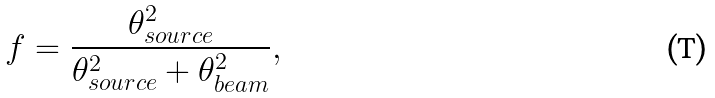Convert formula to latex. <formula><loc_0><loc_0><loc_500><loc_500>f = \frac { \theta _ { s o u r c e } ^ { 2 } } { \theta _ { s o u r c e } ^ { 2 } + \theta _ { b e a m } ^ { 2 } } ,</formula> 